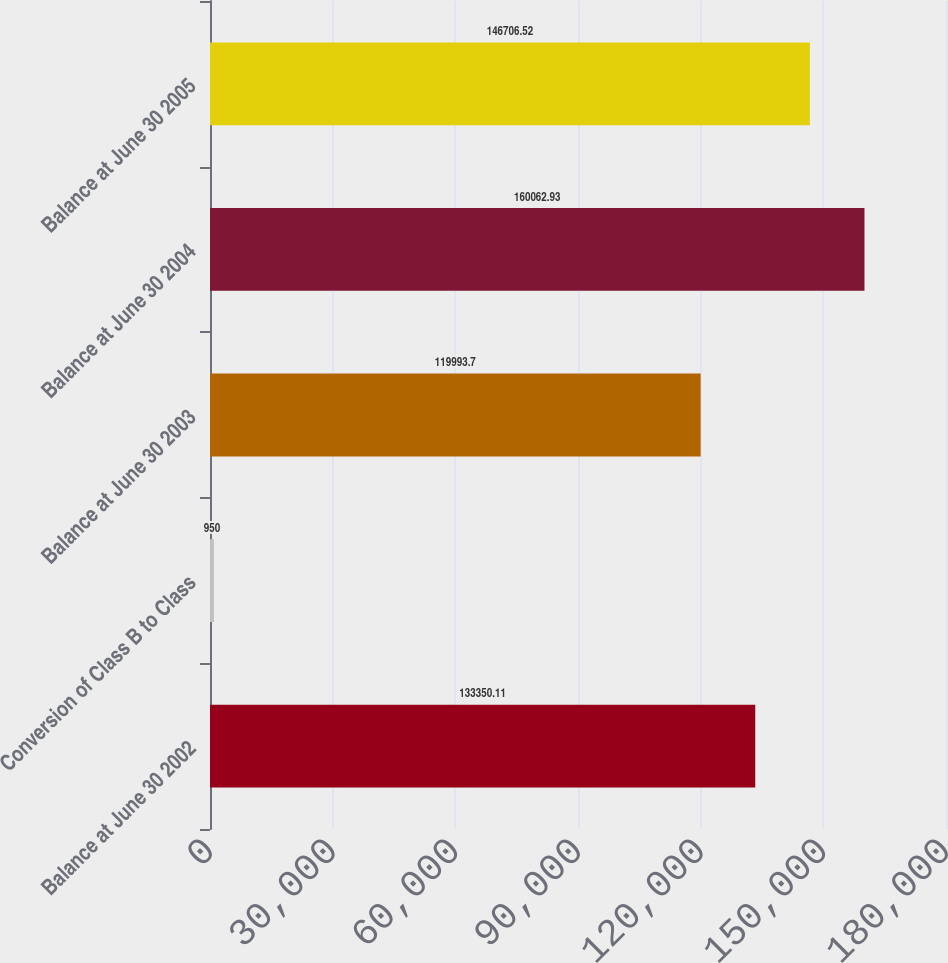Convert chart to OTSL. <chart><loc_0><loc_0><loc_500><loc_500><bar_chart><fcel>Balance at June 30 2002<fcel>Conversion of Class B to Class<fcel>Balance at June 30 2003<fcel>Balance at June 30 2004<fcel>Balance at June 30 2005<nl><fcel>133350<fcel>950<fcel>119994<fcel>160063<fcel>146707<nl></chart> 